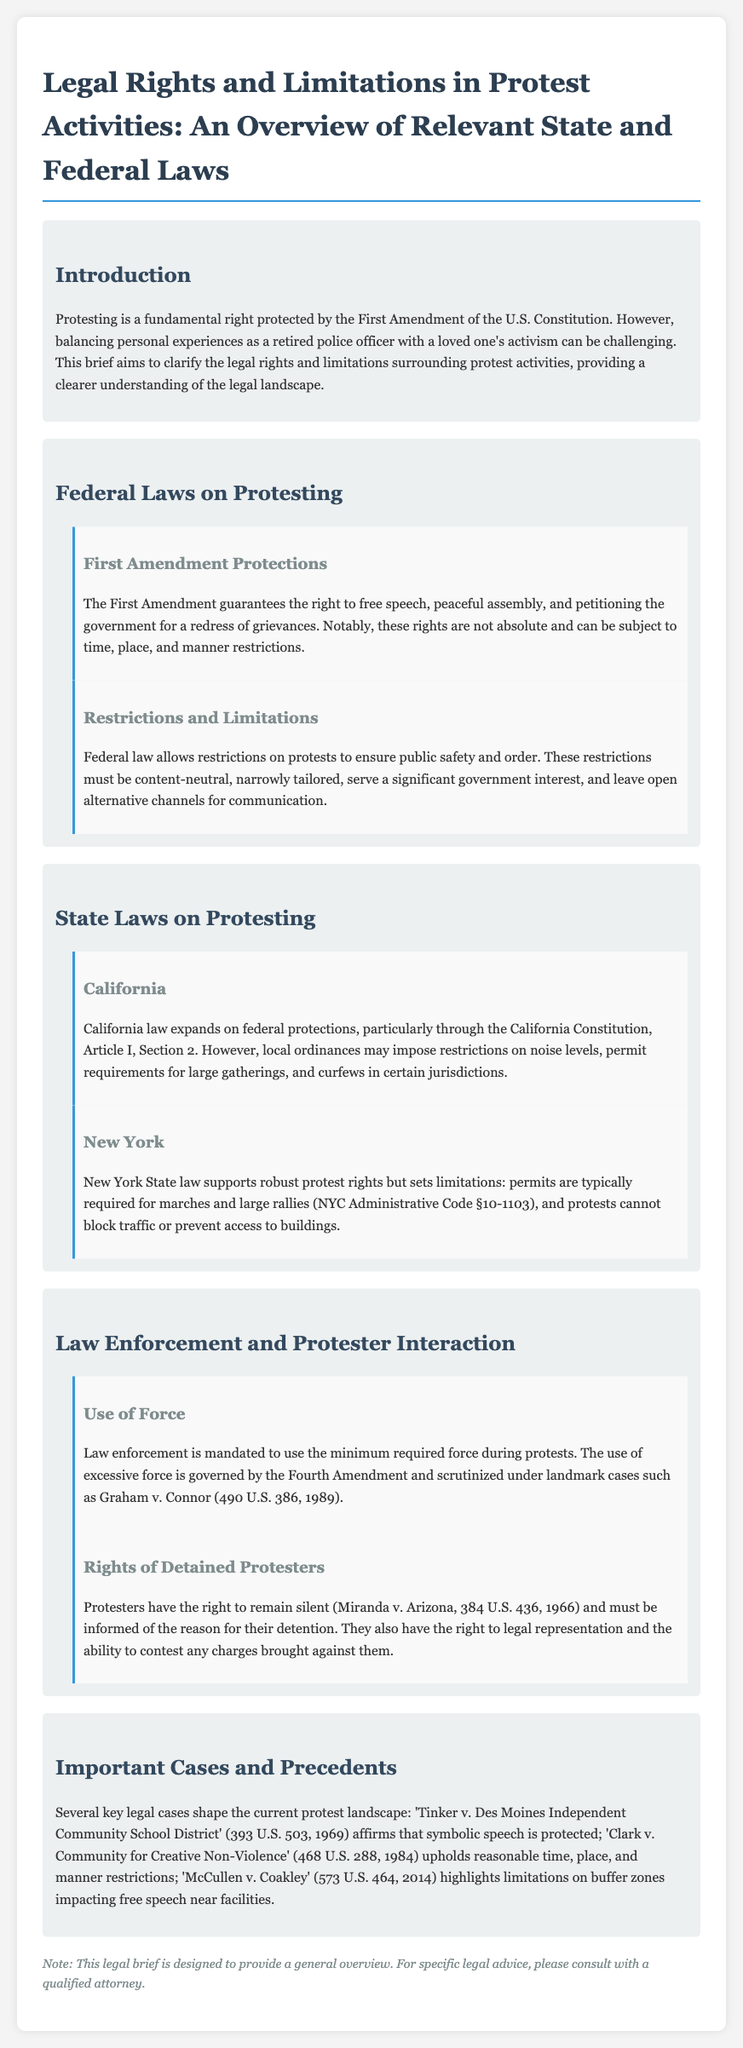What is safeguarded by the First Amendment? The First Amendment guarantees the right to free speech, peaceful assembly, and petitioning the government for a redress of grievances.
Answer: free speech, peaceful assembly, petitioning What must federal restrictions on protests be? Federal law allows restrictions on protests to ensure public safety and order, requiring them to be content-neutral, narrowly tailored, serve a significant government interest, and leave open alternative channels for communication.
Answer: content-neutral, narrowly tailored Which section of the California Constitution addresses protest rights? California law expands on federal protections, particularly through the California Constitution, Article I, Section 2.
Answer: Article I, Section 2 What is required for marches in New York State? New York State law supports robust protest rights but sets limitations that mandates permits typically required for marches and large rallies.
Answer: permits Which case emphasized the right to remain silent for detained protesters? Protesters have the right to remain silent, established by the landmark case Miranda v. Arizona.
Answer: Miranda v. Arizona What must law enforcement use during protests? Law enforcement is mandated to use the minimum required force during protests to ensure public safety.
Answer: minimum required force What does the document note about legal advice? The document notes that for specific legal advice, individuals should consult with a qualified attorney.
Answer: consult with a qualified attorney What significant ruling did 'Tinker v. Des Moines Independent Community School District' affirm? The case affirmed that symbolic speech is protected under the First Amendment.
Answer: symbolic speech is protected 